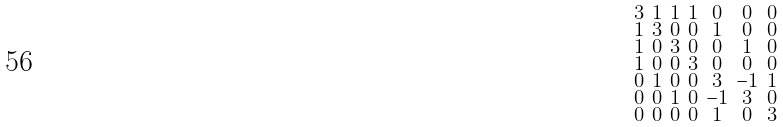Convert formula to latex. <formula><loc_0><loc_0><loc_500><loc_500>\begin{smallmatrix} 3 & 1 & 1 & 1 & 0 & 0 & 0 \\ 1 & 3 & 0 & 0 & 1 & 0 & 0 \\ 1 & 0 & 3 & 0 & 0 & 1 & 0 \\ 1 & 0 & 0 & 3 & 0 & 0 & 0 \\ 0 & 1 & 0 & 0 & 3 & - 1 & 1 \\ 0 & 0 & 1 & 0 & - 1 & 3 & 0 \\ 0 & 0 & 0 & 0 & 1 & 0 & 3 \end{smallmatrix}</formula> 